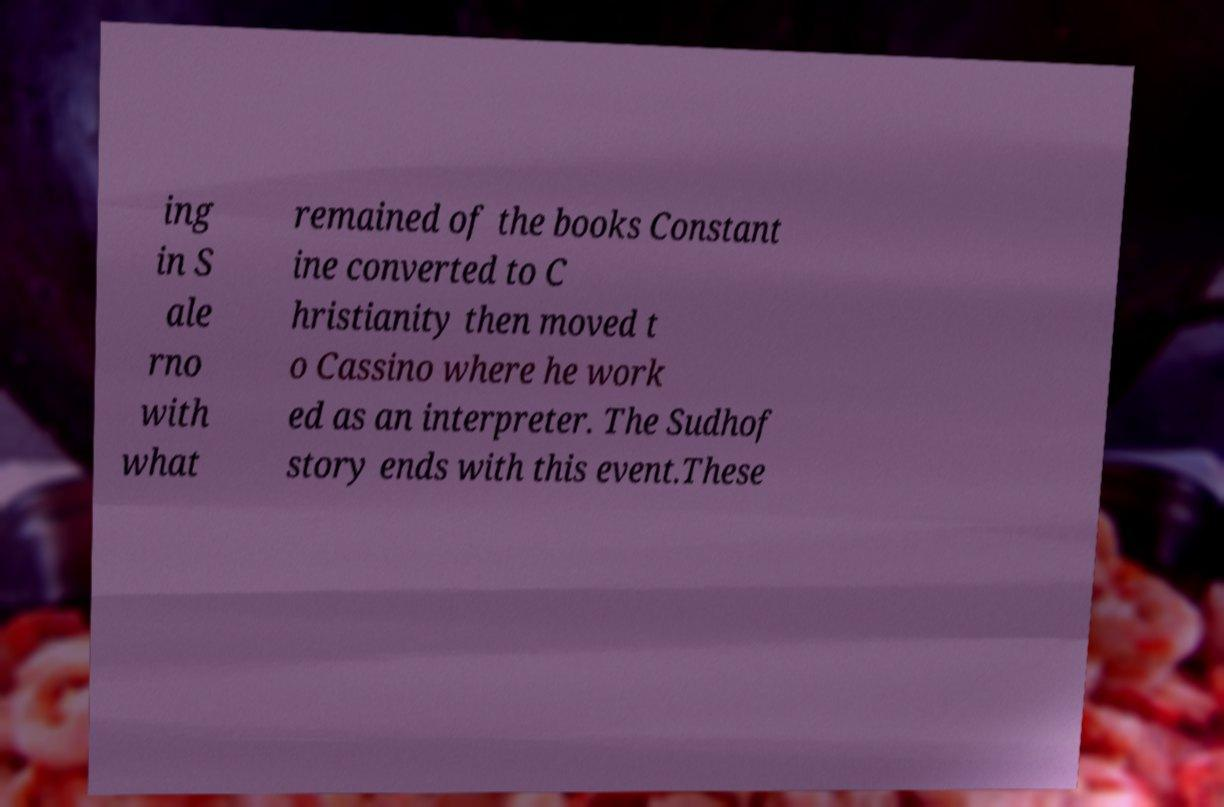For documentation purposes, I need the text within this image transcribed. Could you provide that? ing in S ale rno with what remained of the books Constant ine converted to C hristianity then moved t o Cassino where he work ed as an interpreter. The Sudhof story ends with this event.These 